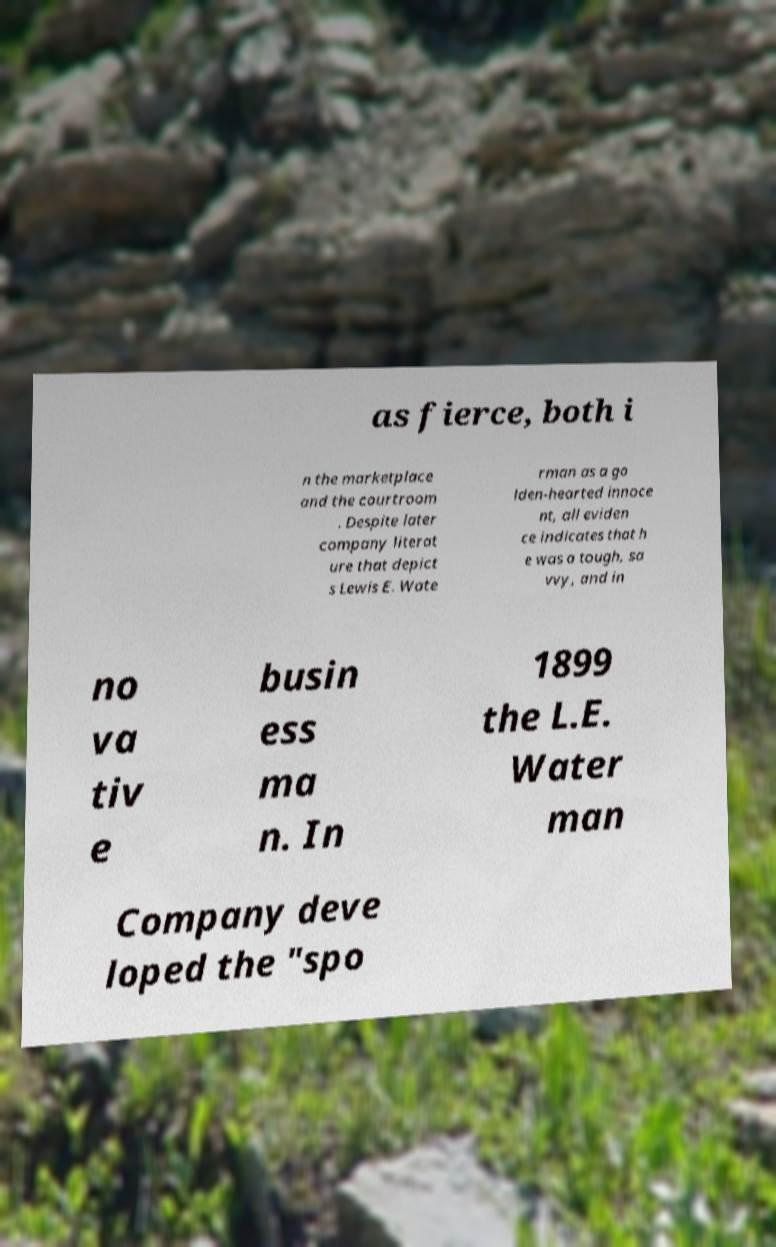Please read and relay the text visible in this image. What does it say? as fierce, both i n the marketplace and the courtroom . Despite later company literat ure that depict s Lewis E. Wate rman as a go lden-hearted innoce nt, all eviden ce indicates that h e was a tough, sa vvy, and in no va tiv e busin ess ma n. In 1899 the L.E. Water man Company deve loped the "spo 